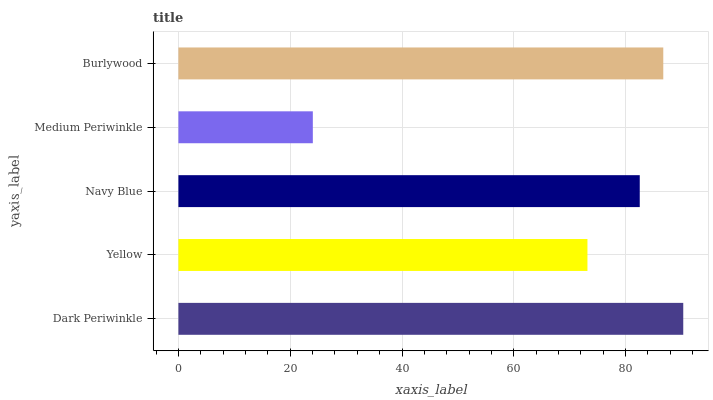Is Medium Periwinkle the minimum?
Answer yes or no. Yes. Is Dark Periwinkle the maximum?
Answer yes or no. Yes. Is Yellow the minimum?
Answer yes or no. No. Is Yellow the maximum?
Answer yes or no. No. Is Dark Periwinkle greater than Yellow?
Answer yes or no. Yes. Is Yellow less than Dark Periwinkle?
Answer yes or no. Yes. Is Yellow greater than Dark Periwinkle?
Answer yes or no. No. Is Dark Periwinkle less than Yellow?
Answer yes or no. No. Is Navy Blue the high median?
Answer yes or no. Yes. Is Navy Blue the low median?
Answer yes or no. Yes. Is Yellow the high median?
Answer yes or no. No. Is Burlywood the low median?
Answer yes or no. No. 